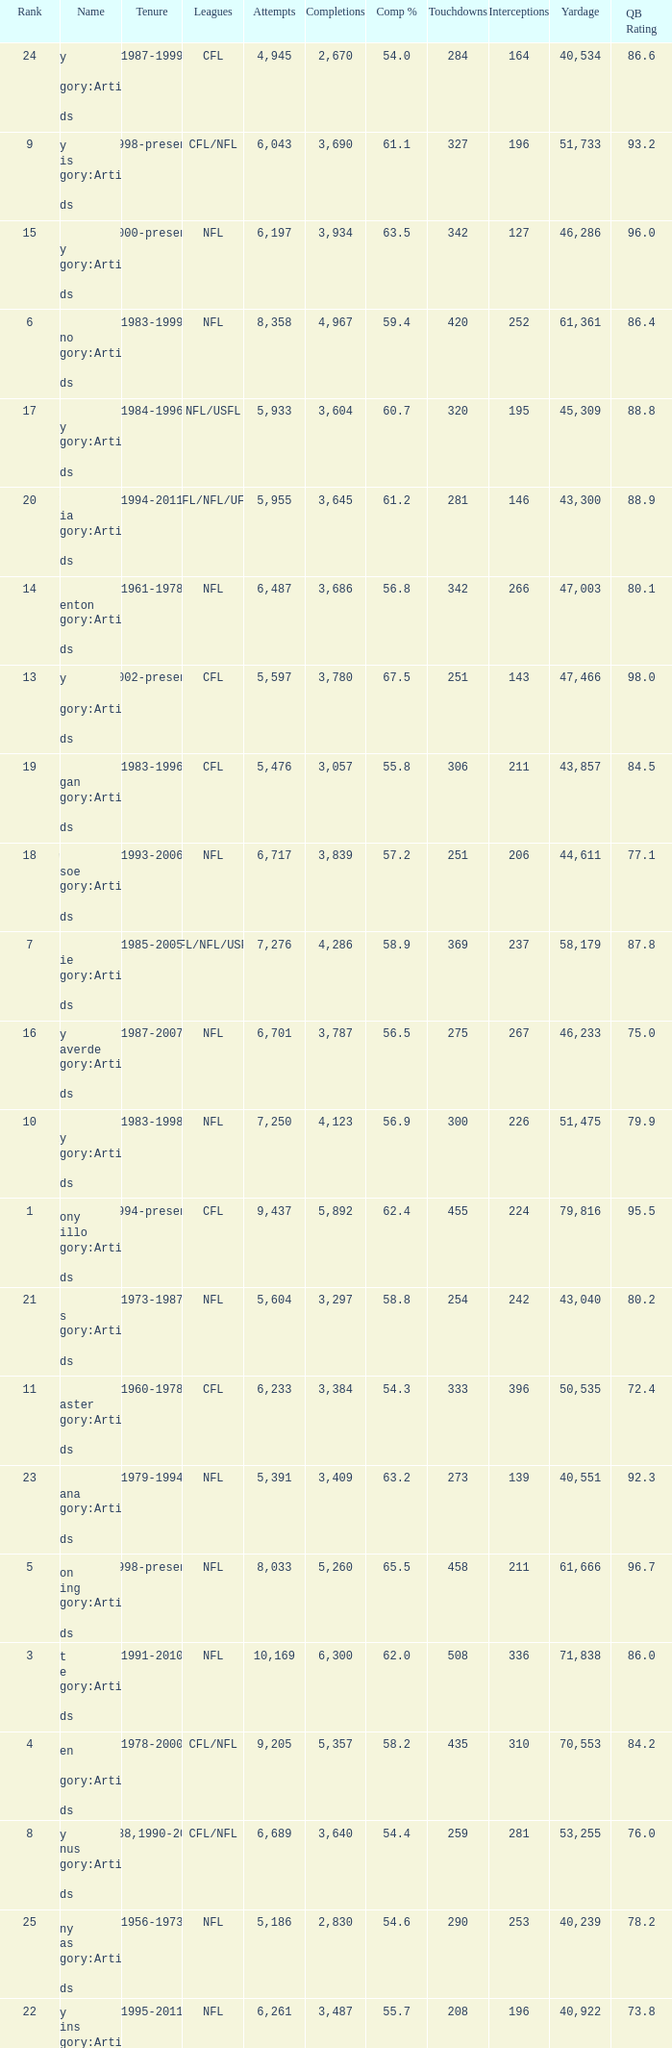What is the number of interceptions with less than 3,487 completions , more than 40,551 yardage, and the comp % is 55.8? 211.0. 